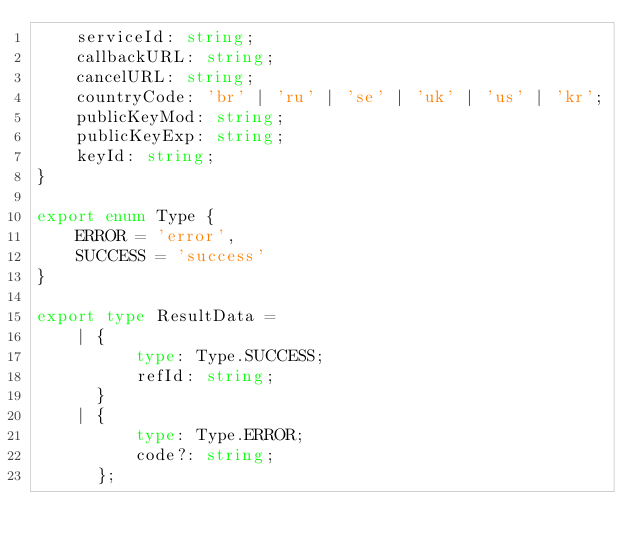Convert code to text. <code><loc_0><loc_0><loc_500><loc_500><_TypeScript_>    serviceId: string;
    callbackURL: string;
    cancelURL: string;
    countryCode: 'br' | 'ru' | 'se' | 'uk' | 'us' | 'kr';
    publicKeyMod: string;
    publicKeyExp: string;
    keyId: string;
}

export enum Type {
    ERROR = 'error',
    SUCCESS = 'success'
}

export type ResultData =
    | {
          type: Type.SUCCESS;
          refId: string;
      }
    | {
          type: Type.ERROR;
          code?: string;
      };
</code> 